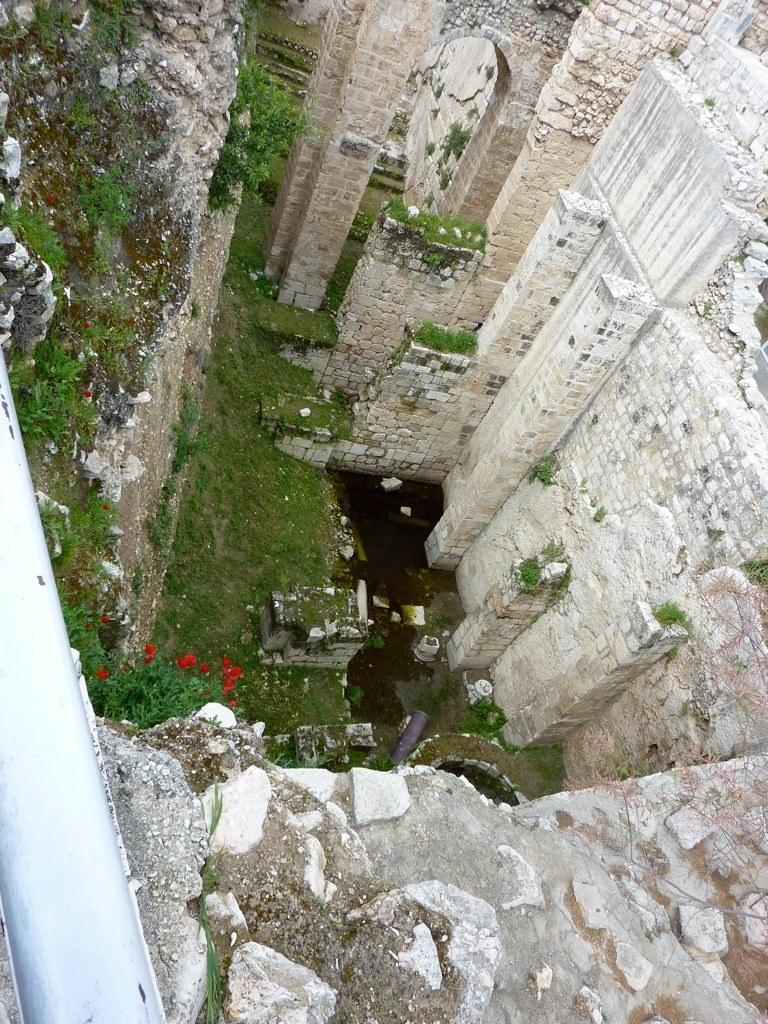What type of structures are present in the image? There are buildings in the image. What colors are the buildings? The buildings are in white and cream colors. What type of flora can be seen in the image? There are flowers and plants in the image. What colors are the flowers and plants? The flowers are red in color, while the plants are green in color. What type of vegetation is present in the image? There is grass in the image, which is also green in color. What year is depicted in the image? The image does not depict a specific year; it is a static representation of buildings, flowers, plants, and grass. Can you tell me how many cups are visible in the image? There are no cups present in the image. 